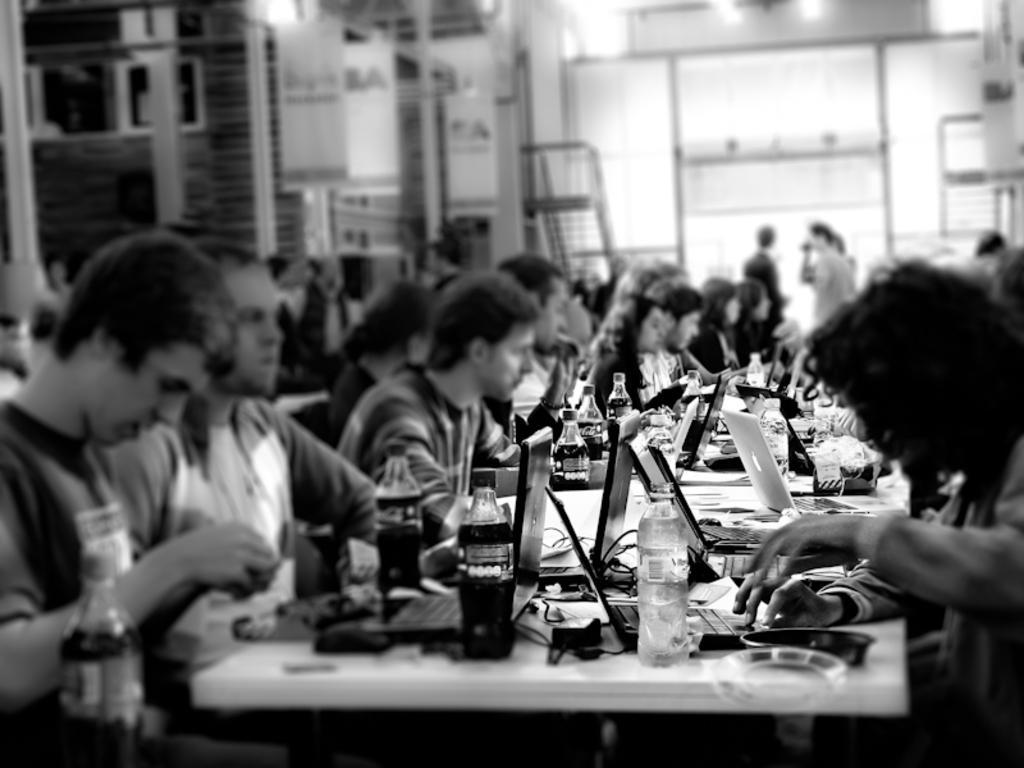Could you give a brief overview of what you see in this image? As we can see in the image there is a wall, banners, a ladder, few group of people sitting on chairs and there are tables. On table there is a bottle, laptops, glasses, bowls and tissues. 